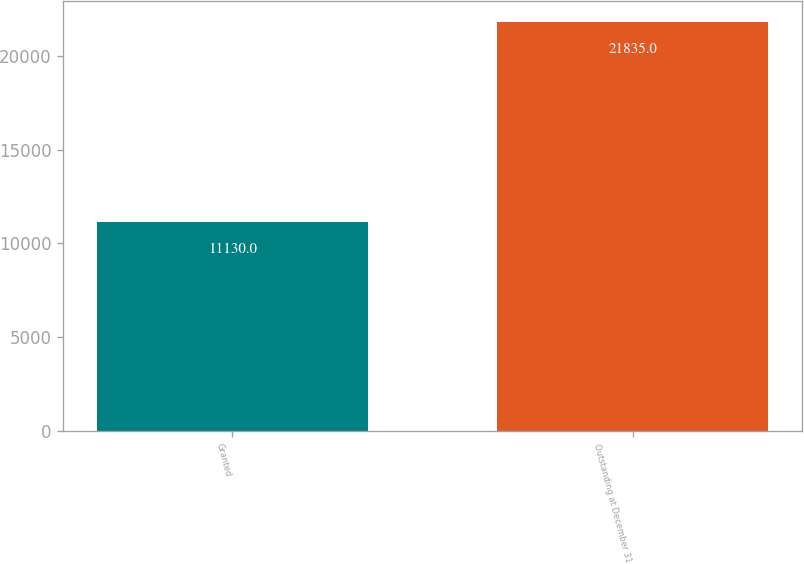<chart> <loc_0><loc_0><loc_500><loc_500><bar_chart><fcel>Granted<fcel>Outstanding at December 31<nl><fcel>11130<fcel>21835<nl></chart> 